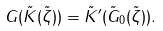Convert formula to latex. <formula><loc_0><loc_0><loc_500><loc_500>G ( \tilde { K } ( \tilde { \zeta } ) ) = \tilde { K } ^ { \prime } ( \tilde { G } _ { 0 } ( \tilde { \zeta } ) ) .</formula> 